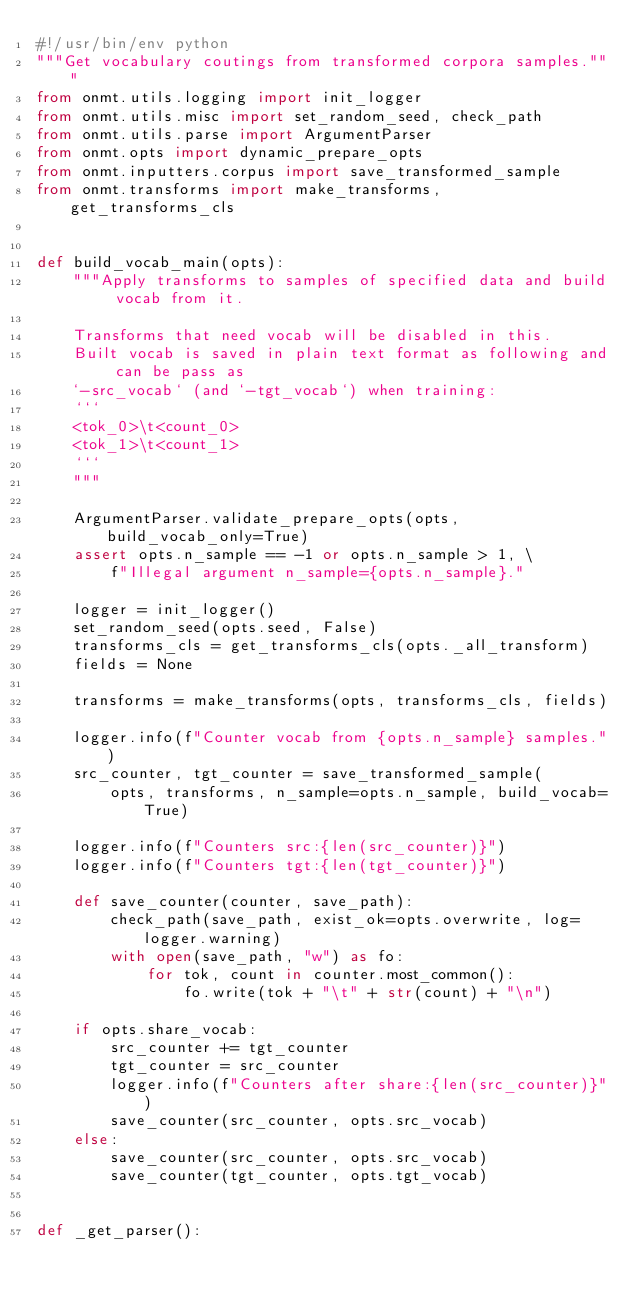<code> <loc_0><loc_0><loc_500><loc_500><_Python_>#!/usr/bin/env python
"""Get vocabulary coutings from transformed corpora samples."""
from onmt.utils.logging import init_logger
from onmt.utils.misc import set_random_seed, check_path
from onmt.utils.parse import ArgumentParser
from onmt.opts import dynamic_prepare_opts
from onmt.inputters.corpus import save_transformed_sample
from onmt.transforms import make_transforms, get_transforms_cls


def build_vocab_main(opts):
    """Apply transforms to samples of specified data and build vocab from it.

    Transforms that need vocab will be disabled in this.
    Built vocab is saved in plain text format as following and can be pass as
    `-src_vocab` (and `-tgt_vocab`) when training:
    ```
    <tok_0>\t<count_0>
    <tok_1>\t<count_1>
    ```
    """

    ArgumentParser.validate_prepare_opts(opts, build_vocab_only=True)
    assert opts.n_sample == -1 or opts.n_sample > 1, \
        f"Illegal argument n_sample={opts.n_sample}."

    logger = init_logger()
    set_random_seed(opts.seed, False)
    transforms_cls = get_transforms_cls(opts._all_transform)
    fields = None

    transforms = make_transforms(opts, transforms_cls, fields)

    logger.info(f"Counter vocab from {opts.n_sample} samples.")
    src_counter, tgt_counter = save_transformed_sample(
        opts, transforms, n_sample=opts.n_sample, build_vocab=True)

    logger.info(f"Counters src:{len(src_counter)}")
    logger.info(f"Counters tgt:{len(tgt_counter)}")

    def save_counter(counter, save_path):
        check_path(save_path, exist_ok=opts.overwrite, log=logger.warning)
        with open(save_path, "w") as fo:
            for tok, count in counter.most_common():
                fo.write(tok + "\t" + str(count) + "\n")

    if opts.share_vocab:
        src_counter += tgt_counter
        tgt_counter = src_counter
        logger.info(f"Counters after share:{len(src_counter)}")
        save_counter(src_counter, opts.src_vocab)
    else:
        save_counter(src_counter, opts.src_vocab)
        save_counter(tgt_counter, opts.tgt_vocab)


def _get_parser():</code> 